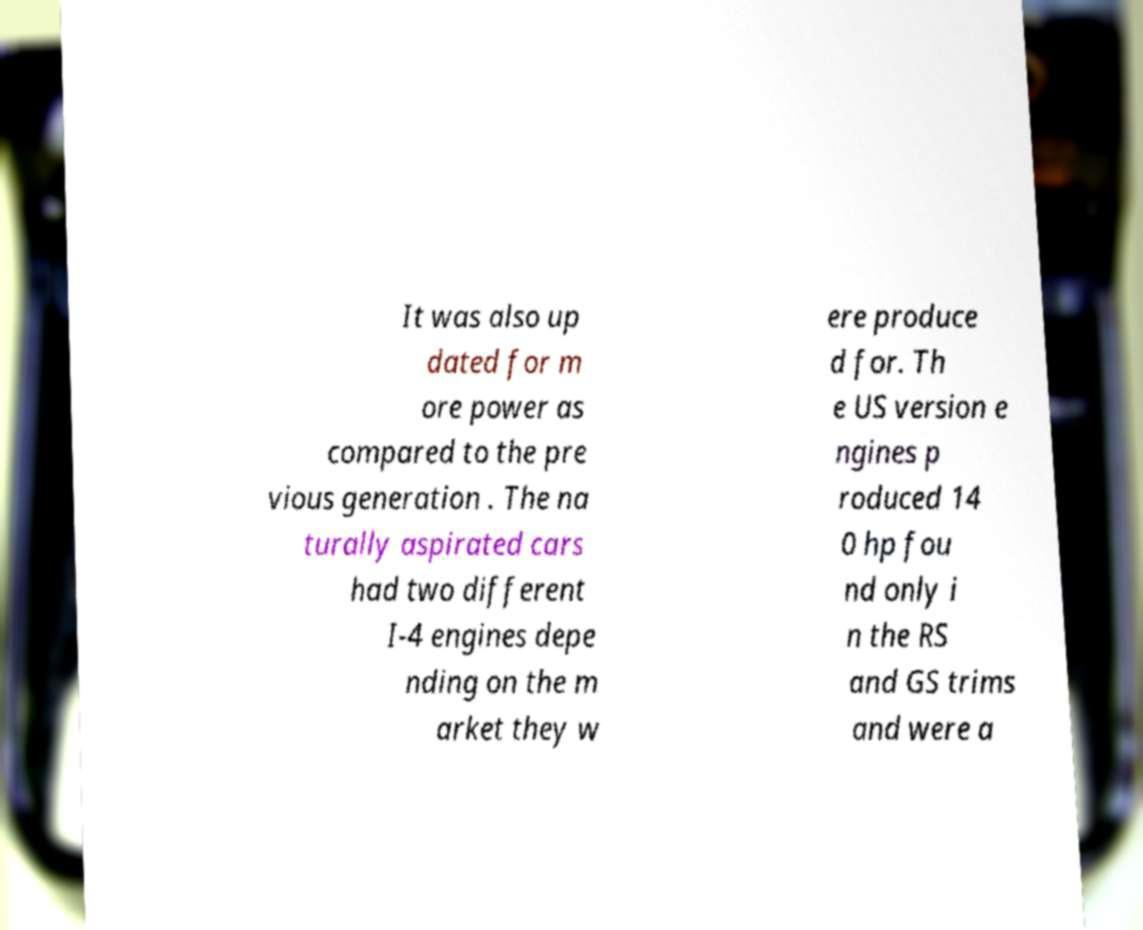Could you assist in decoding the text presented in this image and type it out clearly? It was also up dated for m ore power as compared to the pre vious generation . The na turally aspirated cars had two different I-4 engines depe nding on the m arket they w ere produce d for. Th e US version e ngines p roduced 14 0 hp fou nd only i n the RS and GS trims and were a 